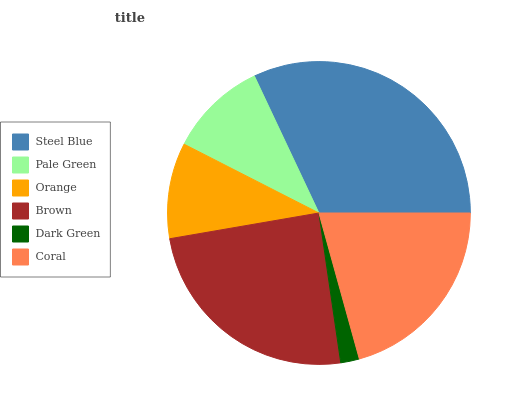Is Dark Green the minimum?
Answer yes or no. Yes. Is Steel Blue the maximum?
Answer yes or no. Yes. Is Pale Green the minimum?
Answer yes or no. No. Is Pale Green the maximum?
Answer yes or no. No. Is Steel Blue greater than Pale Green?
Answer yes or no. Yes. Is Pale Green less than Steel Blue?
Answer yes or no. Yes. Is Pale Green greater than Steel Blue?
Answer yes or no. No. Is Steel Blue less than Pale Green?
Answer yes or no. No. Is Coral the high median?
Answer yes or no. Yes. Is Pale Green the low median?
Answer yes or no. Yes. Is Dark Green the high median?
Answer yes or no. No. Is Dark Green the low median?
Answer yes or no. No. 